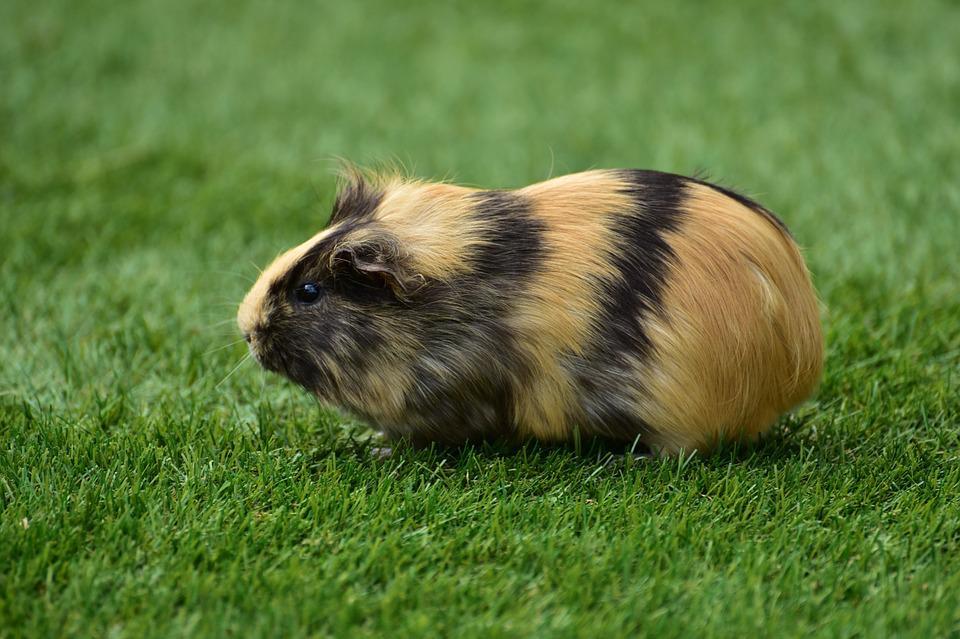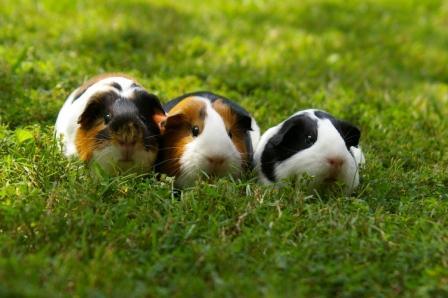The first image is the image on the left, the second image is the image on the right. Evaluate the accuracy of this statement regarding the images: "The right image contains exactly two rodents.". Is it true? Answer yes or no. No. The first image is the image on the left, the second image is the image on the right. For the images shown, is this caption "All guinea pigs are on green grass, and none of them are standing upright." true? Answer yes or no. Yes. 